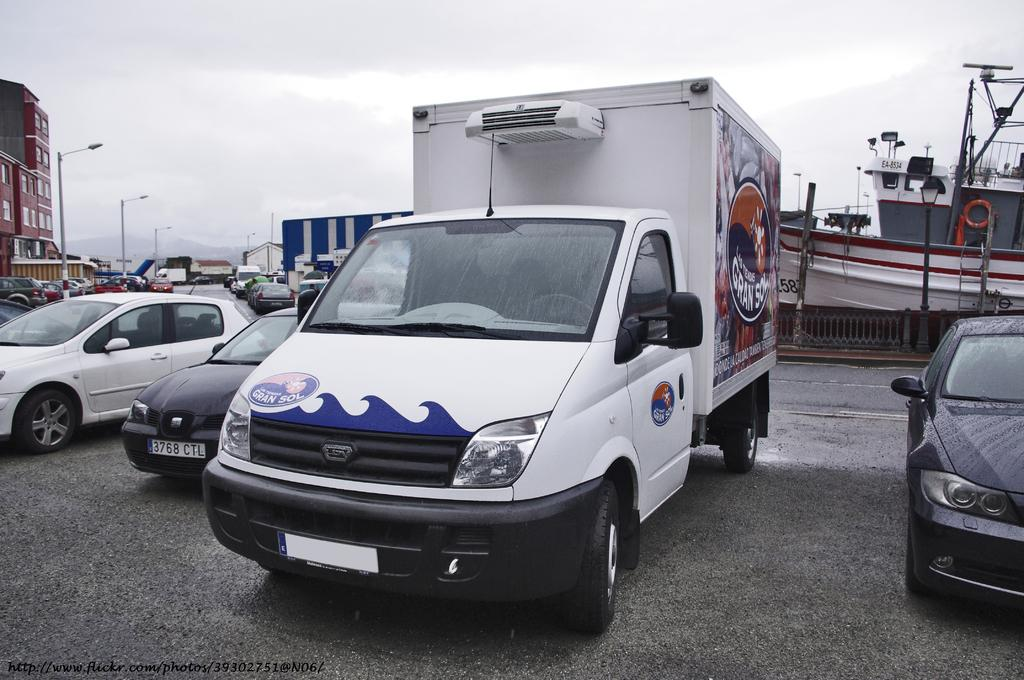What can be seen on the road in the image? There are cars parked on the road in the image. What is visible in the background of the image? There is a ship, buildings, light poles, and the sky visible in the background of the image. What is the condition of the sky in the image? The sky is visible in the background of the image, and clouds are present. How much money is being exchanged between the cars in the image? There is no indication of money being exchanged in the image; it simply shows parked cars on the road. What type of bread can be seen in the image? There is no bread present in the image. 